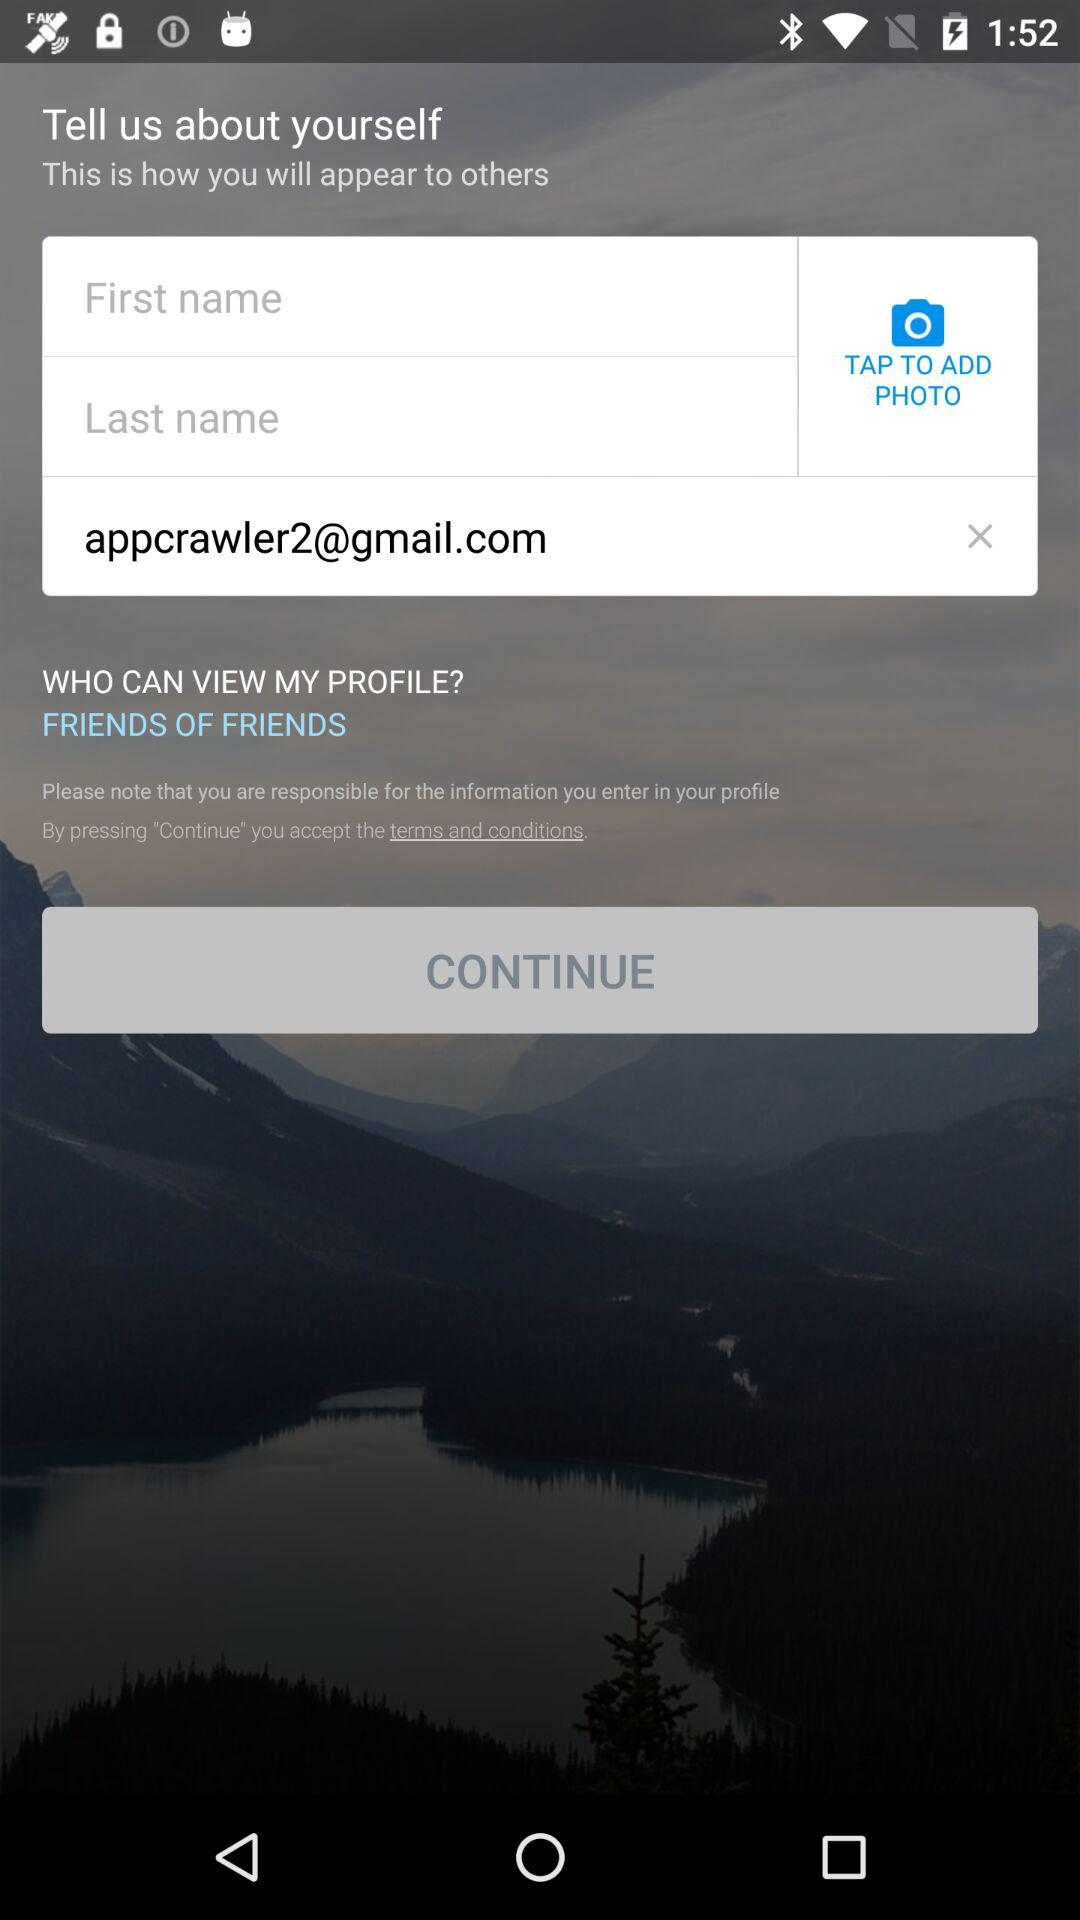What is the email address? The email address is appcrawler2@gmail.com. 